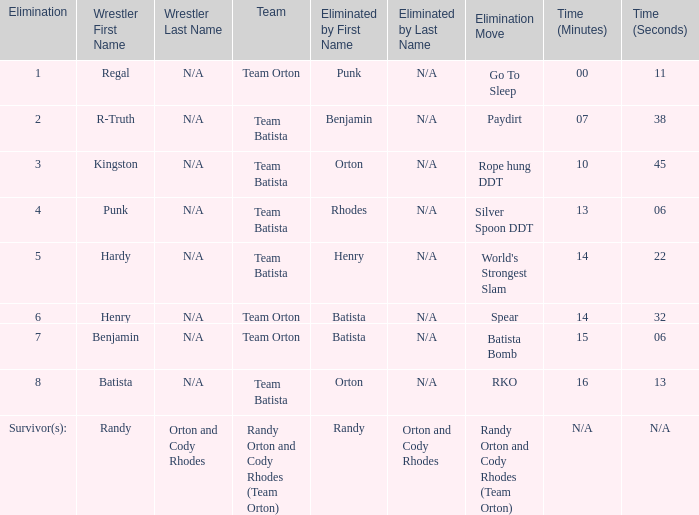Which Wrestler plays for Team Batista which was Elimated by Orton on Elimination 8? Batista. Help me parse the entirety of this table. {'header': ['Elimination', 'Wrestler First Name', 'Wrestler Last Name', 'Team', 'Eliminated by First Name', 'Eliminated by Last Name', 'Elimination Move', 'Time (Minutes)', 'Time (Seconds)'], 'rows': [['1', 'Regal', 'N/A', 'Team Orton', 'Punk', 'N/A', 'Go To Sleep', '00', '11'], ['2', 'R-Truth', 'N/A', 'Team Batista', 'Benjamin', 'N/A', 'Paydirt', '07', '38'], ['3', 'Kingston', 'N/A', 'Team Batista', 'Orton', 'N/A', 'Rope hung DDT', '10', '45'], ['4', 'Punk', 'N/A', 'Team Batista', 'Rhodes', 'N/A', 'Silver Spoon DDT', '13', '06'], ['5', 'Hardy', 'N/A', 'Team Batista', 'Henry', 'N/A', "World's Strongest Slam", '14', '22'], ['6', 'Henry', 'N/A', 'Team Orton', 'Batista', 'N/A', 'Spear', '14', '32'], ['7', 'Benjamin', 'N/A', 'Team Orton', 'Batista', 'N/A', 'Batista Bomb', '15', '06'], ['8', 'Batista', 'N/A', 'Team Batista', 'Orton', 'N/A', 'RKO', '16', '13'], ['Survivor(s):', 'Randy', 'Orton and Cody Rhodes', 'Randy Orton and Cody Rhodes (Team Orton)', 'Randy', 'Orton and Cody Rhodes', 'Randy Orton and Cody Rhodes (Team Orton)', 'N/A', 'N/A']]} 